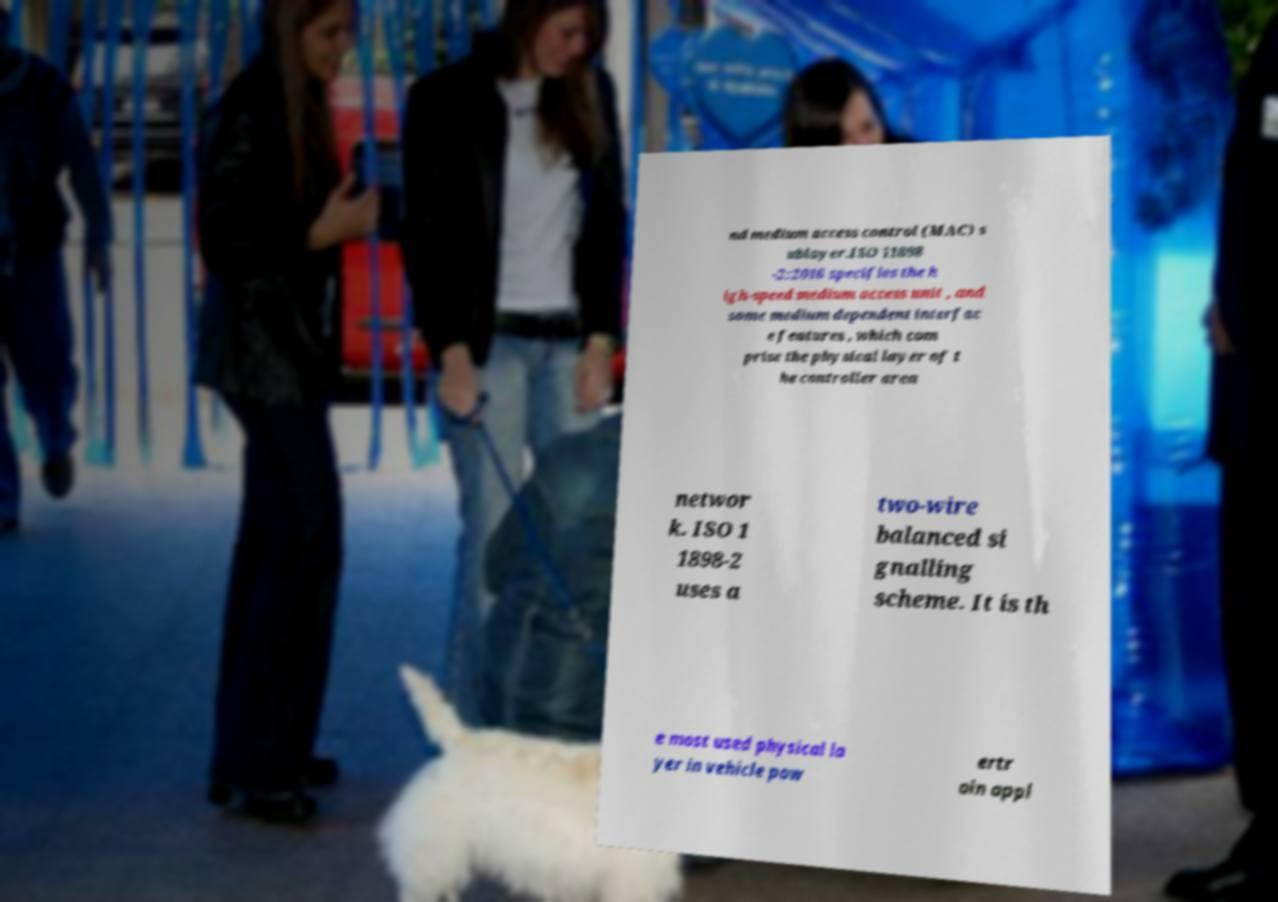Please read and relay the text visible in this image. What does it say? nd medium access control (MAC) s ublayer.ISO 11898 -2:2016 specifies the h igh-speed medium access unit , and some medium dependent interfac e features , which com prise the physical layer of t he controller area networ k. ISO 1 1898-2 uses a two-wire balanced si gnalling scheme. It is th e most used physical la yer in vehicle pow ertr ain appl 